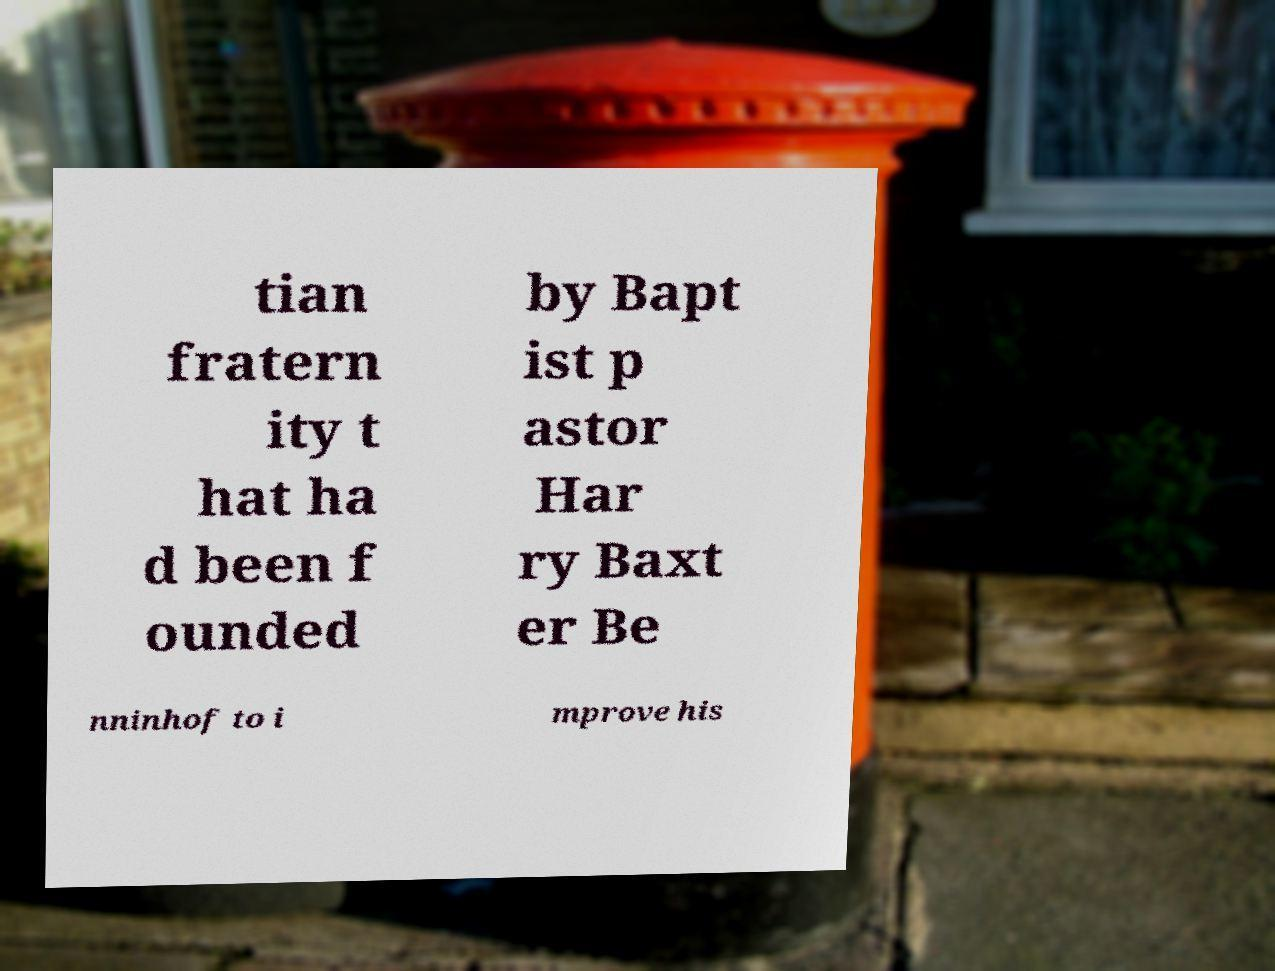Please identify and transcribe the text found in this image. tian fratern ity t hat ha d been f ounded by Bapt ist p astor Har ry Baxt er Be nninhof to i mprove his 